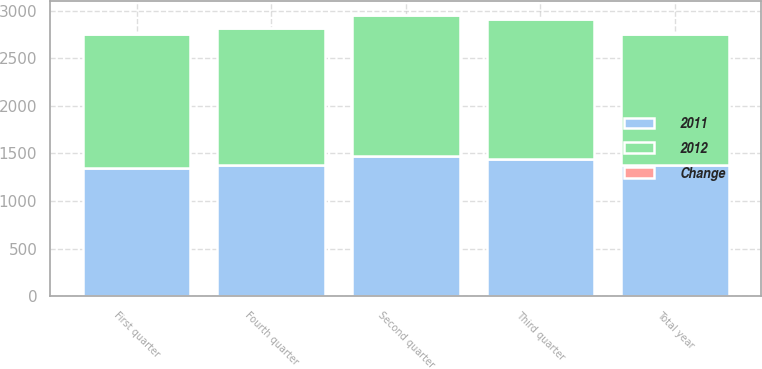Convert chart to OTSL. <chart><loc_0><loc_0><loc_500><loc_500><stacked_bar_chart><ecel><fcel>First quarter<fcel>Second quarter<fcel>Third quarter<fcel>Fourth quarter<fcel>Total year<nl><fcel>2012<fcel>1409<fcel>1469.8<fcel>1473.5<fcel>1435.7<fcel>1378.3<nl><fcel>2011<fcel>1343.6<fcel>1477.9<fcel>1442.5<fcel>1378.3<fcel>1378.3<nl><fcel>Change<fcel>4.9<fcel>0.5<fcel>2.1<fcel>4.2<fcel>2.6<nl></chart> 